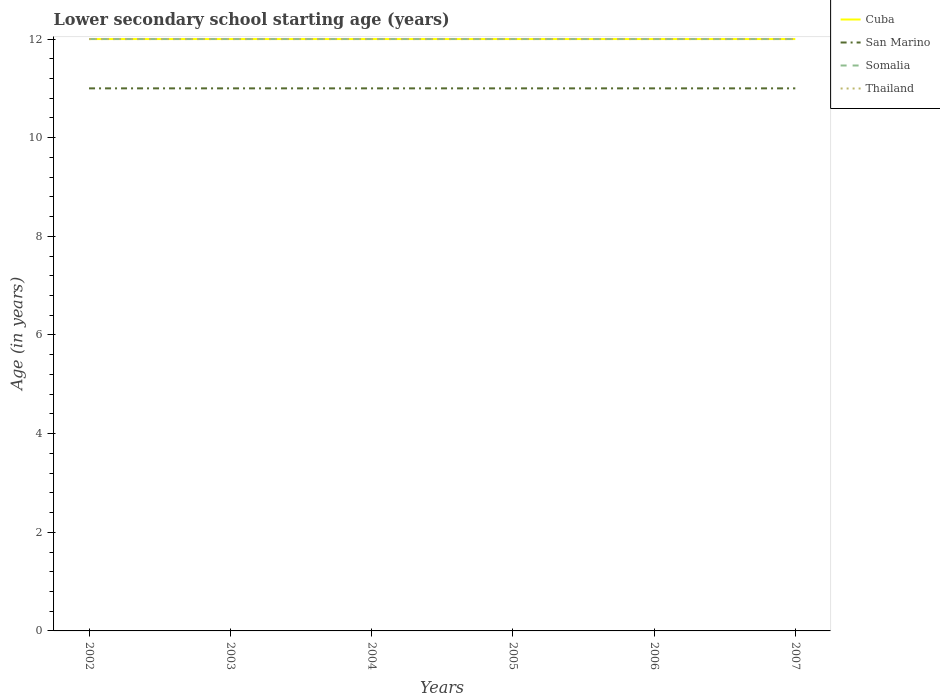Does the line corresponding to Thailand intersect with the line corresponding to Cuba?
Offer a very short reply. Yes. Is the number of lines equal to the number of legend labels?
Keep it short and to the point. Yes. In which year was the lower secondary school starting age of children in San Marino maximum?
Your answer should be compact. 2002. What is the total lower secondary school starting age of children in Thailand in the graph?
Your answer should be compact. 0. What is the difference between the highest and the second highest lower secondary school starting age of children in Somalia?
Your response must be concise. 0. How many years are there in the graph?
Provide a short and direct response. 6. Are the values on the major ticks of Y-axis written in scientific E-notation?
Your answer should be very brief. No. Does the graph contain any zero values?
Your answer should be compact. No. Where does the legend appear in the graph?
Provide a short and direct response. Top right. How many legend labels are there?
Your answer should be very brief. 4. What is the title of the graph?
Provide a succinct answer. Lower secondary school starting age (years). What is the label or title of the X-axis?
Your answer should be compact. Years. What is the label or title of the Y-axis?
Your response must be concise. Age (in years). What is the Age (in years) of San Marino in 2002?
Ensure brevity in your answer.  11. What is the Age (in years) in Somalia in 2002?
Offer a terse response. 12. What is the Age (in years) in Thailand in 2002?
Your response must be concise. 12. What is the Age (in years) in Cuba in 2003?
Your answer should be very brief. 12. What is the Age (in years) in San Marino in 2003?
Offer a terse response. 11. What is the Age (in years) of Somalia in 2003?
Make the answer very short. 12. What is the Age (in years) of Cuba in 2004?
Make the answer very short. 12. What is the Age (in years) of San Marino in 2004?
Give a very brief answer. 11. What is the Age (in years) of Cuba in 2005?
Offer a terse response. 12. What is the Age (in years) of San Marino in 2005?
Offer a terse response. 11. What is the Age (in years) in Cuba in 2006?
Make the answer very short. 12. What is the Age (in years) of San Marino in 2006?
Make the answer very short. 11. What is the Age (in years) in Somalia in 2006?
Provide a short and direct response. 12. What is the Age (in years) of Thailand in 2006?
Your answer should be compact. 12. What is the Age (in years) in Cuba in 2007?
Provide a short and direct response. 12. What is the Age (in years) in San Marino in 2007?
Ensure brevity in your answer.  11. Across all years, what is the minimum Age (in years) of Somalia?
Your answer should be compact. 12. Across all years, what is the minimum Age (in years) of Thailand?
Offer a terse response. 12. What is the total Age (in years) in Thailand in the graph?
Keep it short and to the point. 72. What is the difference between the Age (in years) in San Marino in 2002 and that in 2003?
Offer a very short reply. 0. What is the difference between the Age (in years) of Cuba in 2002 and that in 2004?
Your answer should be very brief. 0. What is the difference between the Age (in years) in San Marino in 2002 and that in 2004?
Give a very brief answer. 0. What is the difference between the Age (in years) of Somalia in 2002 and that in 2004?
Your response must be concise. 0. What is the difference between the Age (in years) of Somalia in 2002 and that in 2006?
Your response must be concise. 0. What is the difference between the Age (in years) of San Marino in 2003 and that in 2004?
Keep it short and to the point. 0. What is the difference between the Age (in years) of Somalia in 2003 and that in 2004?
Your answer should be very brief. 0. What is the difference between the Age (in years) in Thailand in 2003 and that in 2004?
Give a very brief answer. 0. What is the difference between the Age (in years) of San Marino in 2003 and that in 2005?
Make the answer very short. 0. What is the difference between the Age (in years) in Thailand in 2003 and that in 2005?
Ensure brevity in your answer.  0. What is the difference between the Age (in years) of San Marino in 2003 and that in 2006?
Provide a succinct answer. 0. What is the difference between the Age (in years) of Thailand in 2003 and that in 2006?
Keep it short and to the point. 0. What is the difference between the Age (in years) of Cuba in 2003 and that in 2007?
Ensure brevity in your answer.  0. What is the difference between the Age (in years) of San Marino in 2003 and that in 2007?
Offer a very short reply. 0. What is the difference between the Age (in years) of Thailand in 2003 and that in 2007?
Your answer should be very brief. 0. What is the difference between the Age (in years) of San Marino in 2004 and that in 2005?
Keep it short and to the point. 0. What is the difference between the Age (in years) of Somalia in 2004 and that in 2005?
Give a very brief answer. 0. What is the difference between the Age (in years) in Somalia in 2004 and that in 2006?
Provide a succinct answer. 0. What is the difference between the Age (in years) of Cuba in 2004 and that in 2007?
Your answer should be very brief. 0. What is the difference between the Age (in years) of San Marino in 2004 and that in 2007?
Provide a succinct answer. 0. What is the difference between the Age (in years) of Cuba in 2005 and that in 2006?
Your answer should be very brief. 0. What is the difference between the Age (in years) in Somalia in 2005 and that in 2006?
Keep it short and to the point. 0. What is the difference between the Age (in years) of Cuba in 2005 and that in 2007?
Give a very brief answer. 0. What is the difference between the Age (in years) in Somalia in 2005 and that in 2007?
Your response must be concise. 0. What is the difference between the Age (in years) in Thailand in 2005 and that in 2007?
Ensure brevity in your answer.  0. What is the difference between the Age (in years) in Somalia in 2006 and that in 2007?
Give a very brief answer. 0. What is the difference between the Age (in years) in Cuba in 2002 and the Age (in years) in Somalia in 2003?
Provide a short and direct response. 0. What is the difference between the Age (in years) in Cuba in 2002 and the Age (in years) in Thailand in 2003?
Your answer should be very brief. 0. What is the difference between the Age (in years) of San Marino in 2002 and the Age (in years) of Somalia in 2003?
Provide a succinct answer. -1. What is the difference between the Age (in years) of San Marino in 2002 and the Age (in years) of Thailand in 2003?
Provide a succinct answer. -1. What is the difference between the Age (in years) of Cuba in 2002 and the Age (in years) of San Marino in 2004?
Offer a terse response. 1. What is the difference between the Age (in years) in Cuba in 2002 and the Age (in years) in Thailand in 2004?
Your answer should be compact. 0. What is the difference between the Age (in years) in San Marino in 2002 and the Age (in years) in Somalia in 2004?
Your answer should be compact. -1. What is the difference between the Age (in years) of Somalia in 2002 and the Age (in years) of Thailand in 2004?
Keep it short and to the point. 0. What is the difference between the Age (in years) in Cuba in 2002 and the Age (in years) in San Marino in 2005?
Offer a very short reply. 1. What is the difference between the Age (in years) of San Marino in 2002 and the Age (in years) of Thailand in 2005?
Offer a very short reply. -1. What is the difference between the Age (in years) in Somalia in 2002 and the Age (in years) in Thailand in 2005?
Your answer should be compact. 0. What is the difference between the Age (in years) of Cuba in 2002 and the Age (in years) of San Marino in 2006?
Offer a very short reply. 1. What is the difference between the Age (in years) in Cuba in 2002 and the Age (in years) in Thailand in 2006?
Your response must be concise. 0. What is the difference between the Age (in years) in San Marino in 2002 and the Age (in years) in Thailand in 2006?
Your response must be concise. -1. What is the difference between the Age (in years) of Somalia in 2002 and the Age (in years) of Thailand in 2006?
Provide a succinct answer. 0. What is the difference between the Age (in years) in San Marino in 2002 and the Age (in years) in Somalia in 2007?
Offer a very short reply. -1. What is the difference between the Age (in years) of San Marino in 2002 and the Age (in years) of Thailand in 2007?
Your response must be concise. -1. What is the difference between the Age (in years) in Cuba in 2003 and the Age (in years) in Somalia in 2004?
Keep it short and to the point. 0. What is the difference between the Age (in years) in Cuba in 2003 and the Age (in years) in San Marino in 2005?
Make the answer very short. 1. What is the difference between the Age (in years) in Cuba in 2003 and the Age (in years) in Somalia in 2005?
Provide a succinct answer. 0. What is the difference between the Age (in years) in San Marino in 2003 and the Age (in years) in Thailand in 2005?
Your answer should be very brief. -1. What is the difference between the Age (in years) in Cuba in 2003 and the Age (in years) in San Marino in 2006?
Ensure brevity in your answer.  1. What is the difference between the Age (in years) of Somalia in 2003 and the Age (in years) of Thailand in 2006?
Provide a succinct answer. 0. What is the difference between the Age (in years) of Cuba in 2003 and the Age (in years) of San Marino in 2007?
Make the answer very short. 1. What is the difference between the Age (in years) of Somalia in 2003 and the Age (in years) of Thailand in 2007?
Make the answer very short. 0. What is the difference between the Age (in years) in Cuba in 2004 and the Age (in years) in San Marino in 2005?
Provide a short and direct response. 1. What is the difference between the Age (in years) of Cuba in 2004 and the Age (in years) of Thailand in 2005?
Your answer should be compact. 0. What is the difference between the Age (in years) of San Marino in 2004 and the Age (in years) of Somalia in 2005?
Ensure brevity in your answer.  -1. What is the difference between the Age (in years) in Cuba in 2004 and the Age (in years) in San Marino in 2006?
Offer a terse response. 1. What is the difference between the Age (in years) in San Marino in 2004 and the Age (in years) in Somalia in 2006?
Give a very brief answer. -1. What is the difference between the Age (in years) of Somalia in 2004 and the Age (in years) of Thailand in 2006?
Offer a terse response. 0. What is the difference between the Age (in years) of San Marino in 2004 and the Age (in years) of Thailand in 2007?
Keep it short and to the point. -1. What is the difference between the Age (in years) of Somalia in 2004 and the Age (in years) of Thailand in 2007?
Your answer should be compact. 0. What is the difference between the Age (in years) of Cuba in 2005 and the Age (in years) of Somalia in 2006?
Your response must be concise. 0. What is the difference between the Age (in years) of Cuba in 2005 and the Age (in years) of Thailand in 2006?
Your response must be concise. 0. What is the difference between the Age (in years) in Cuba in 2005 and the Age (in years) in Somalia in 2007?
Keep it short and to the point. 0. What is the difference between the Age (in years) in Cuba in 2005 and the Age (in years) in Thailand in 2007?
Your response must be concise. 0. What is the difference between the Age (in years) of San Marino in 2005 and the Age (in years) of Thailand in 2007?
Your answer should be very brief. -1. What is the difference between the Age (in years) of Cuba in 2006 and the Age (in years) of Somalia in 2007?
Your answer should be very brief. 0. What is the difference between the Age (in years) of San Marino in 2006 and the Age (in years) of Somalia in 2007?
Provide a short and direct response. -1. What is the difference between the Age (in years) in San Marino in 2006 and the Age (in years) in Thailand in 2007?
Give a very brief answer. -1. What is the average Age (in years) of San Marino per year?
Make the answer very short. 11. What is the average Age (in years) of Thailand per year?
Keep it short and to the point. 12. In the year 2002, what is the difference between the Age (in years) of Cuba and Age (in years) of San Marino?
Your answer should be very brief. 1. In the year 2002, what is the difference between the Age (in years) in Cuba and Age (in years) in Somalia?
Make the answer very short. 0. In the year 2002, what is the difference between the Age (in years) in Cuba and Age (in years) in Thailand?
Your answer should be very brief. 0. In the year 2002, what is the difference between the Age (in years) of Somalia and Age (in years) of Thailand?
Provide a succinct answer. 0. In the year 2003, what is the difference between the Age (in years) in San Marino and Age (in years) in Thailand?
Your answer should be very brief. -1. In the year 2004, what is the difference between the Age (in years) in Cuba and Age (in years) in San Marino?
Your answer should be compact. 1. In the year 2004, what is the difference between the Age (in years) in San Marino and Age (in years) in Somalia?
Offer a very short reply. -1. In the year 2004, what is the difference between the Age (in years) in Somalia and Age (in years) in Thailand?
Offer a very short reply. 0. In the year 2005, what is the difference between the Age (in years) in Cuba and Age (in years) in San Marino?
Your response must be concise. 1. In the year 2005, what is the difference between the Age (in years) in Cuba and Age (in years) in Somalia?
Give a very brief answer. 0. In the year 2005, what is the difference between the Age (in years) in San Marino and Age (in years) in Somalia?
Your answer should be very brief. -1. In the year 2005, what is the difference between the Age (in years) of San Marino and Age (in years) of Thailand?
Provide a succinct answer. -1. In the year 2006, what is the difference between the Age (in years) of Cuba and Age (in years) of San Marino?
Ensure brevity in your answer.  1. In the year 2006, what is the difference between the Age (in years) of Cuba and Age (in years) of Somalia?
Give a very brief answer. 0. In the year 2006, what is the difference between the Age (in years) in Cuba and Age (in years) in Thailand?
Your answer should be very brief. 0. In the year 2006, what is the difference between the Age (in years) in San Marino and Age (in years) in Thailand?
Your answer should be very brief. -1. In the year 2007, what is the difference between the Age (in years) of Cuba and Age (in years) of Somalia?
Keep it short and to the point. 0. In the year 2007, what is the difference between the Age (in years) of San Marino and Age (in years) of Thailand?
Offer a very short reply. -1. What is the ratio of the Age (in years) in San Marino in 2002 to that in 2003?
Your answer should be compact. 1. What is the ratio of the Age (in years) in San Marino in 2002 to that in 2004?
Provide a succinct answer. 1. What is the ratio of the Age (in years) of Thailand in 2002 to that in 2004?
Offer a very short reply. 1. What is the ratio of the Age (in years) of San Marino in 2002 to that in 2005?
Offer a terse response. 1. What is the ratio of the Age (in years) of Somalia in 2002 to that in 2005?
Your answer should be compact. 1. What is the ratio of the Age (in years) in Thailand in 2002 to that in 2005?
Your answer should be compact. 1. What is the ratio of the Age (in years) of Somalia in 2002 to that in 2006?
Make the answer very short. 1. What is the ratio of the Age (in years) in Cuba in 2002 to that in 2007?
Ensure brevity in your answer.  1. What is the ratio of the Age (in years) of Somalia in 2002 to that in 2007?
Ensure brevity in your answer.  1. What is the ratio of the Age (in years) of Cuba in 2003 to that in 2004?
Offer a very short reply. 1. What is the ratio of the Age (in years) of San Marino in 2003 to that in 2004?
Make the answer very short. 1. What is the ratio of the Age (in years) of Somalia in 2003 to that in 2004?
Provide a succinct answer. 1. What is the ratio of the Age (in years) in Thailand in 2003 to that in 2004?
Provide a short and direct response. 1. What is the ratio of the Age (in years) of Cuba in 2003 to that in 2005?
Give a very brief answer. 1. What is the ratio of the Age (in years) of San Marino in 2003 to that in 2005?
Offer a very short reply. 1. What is the ratio of the Age (in years) in Somalia in 2003 to that in 2005?
Ensure brevity in your answer.  1. What is the ratio of the Age (in years) in Thailand in 2003 to that in 2005?
Your answer should be compact. 1. What is the ratio of the Age (in years) of Cuba in 2003 to that in 2006?
Offer a terse response. 1. What is the ratio of the Age (in years) of San Marino in 2003 to that in 2006?
Ensure brevity in your answer.  1. What is the ratio of the Age (in years) in Thailand in 2003 to that in 2006?
Provide a succinct answer. 1. What is the ratio of the Age (in years) in Thailand in 2003 to that in 2007?
Offer a terse response. 1. What is the ratio of the Age (in years) of Cuba in 2004 to that in 2005?
Your answer should be very brief. 1. What is the ratio of the Age (in years) in San Marino in 2004 to that in 2005?
Your response must be concise. 1. What is the ratio of the Age (in years) of Thailand in 2004 to that in 2005?
Your answer should be very brief. 1. What is the ratio of the Age (in years) of San Marino in 2004 to that in 2006?
Make the answer very short. 1. What is the ratio of the Age (in years) in Somalia in 2004 to that in 2006?
Provide a succinct answer. 1. What is the ratio of the Age (in years) of Thailand in 2004 to that in 2006?
Ensure brevity in your answer.  1. What is the ratio of the Age (in years) in Cuba in 2004 to that in 2007?
Provide a short and direct response. 1. What is the ratio of the Age (in years) of San Marino in 2005 to that in 2006?
Offer a very short reply. 1. What is the ratio of the Age (in years) of Somalia in 2005 to that in 2006?
Provide a short and direct response. 1. What is the ratio of the Age (in years) of San Marino in 2005 to that in 2007?
Ensure brevity in your answer.  1. What is the ratio of the Age (in years) of Somalia in 2005 to that in 2007?
Offer a terse response. 1. What is the ratio of the Age (in years) in Cuba in 2006 to that in 2007?
Ensure brevity in your answer.  1. What is the ratio of the Age (in years) in San Marino in 2006 to that in 2007?
Provide a short and direct response. 1. What is the ratio of the Age (in years) of Somalia in 2006 to that in 2007?
Your answer should be very brief. 1. What is the ratio of the Age (in years) in Thailand in 2006 to that in 2007?
Your answer should be compact. 1. What is the difference between the highest and the second highest Age (in years) of San Marino?
Make the answer very short. 0. What is the difference between the highest and the second highest Age (in years) in Thailand?
Provide a succinct answer. 0. What is the difference between the highest and the lowest Age (in years) of San Marino?
Offer a terse response. 0. What is the difference between the highest and the lowest Age (in years) in Somalia?
Offer a very short reply. 0. 